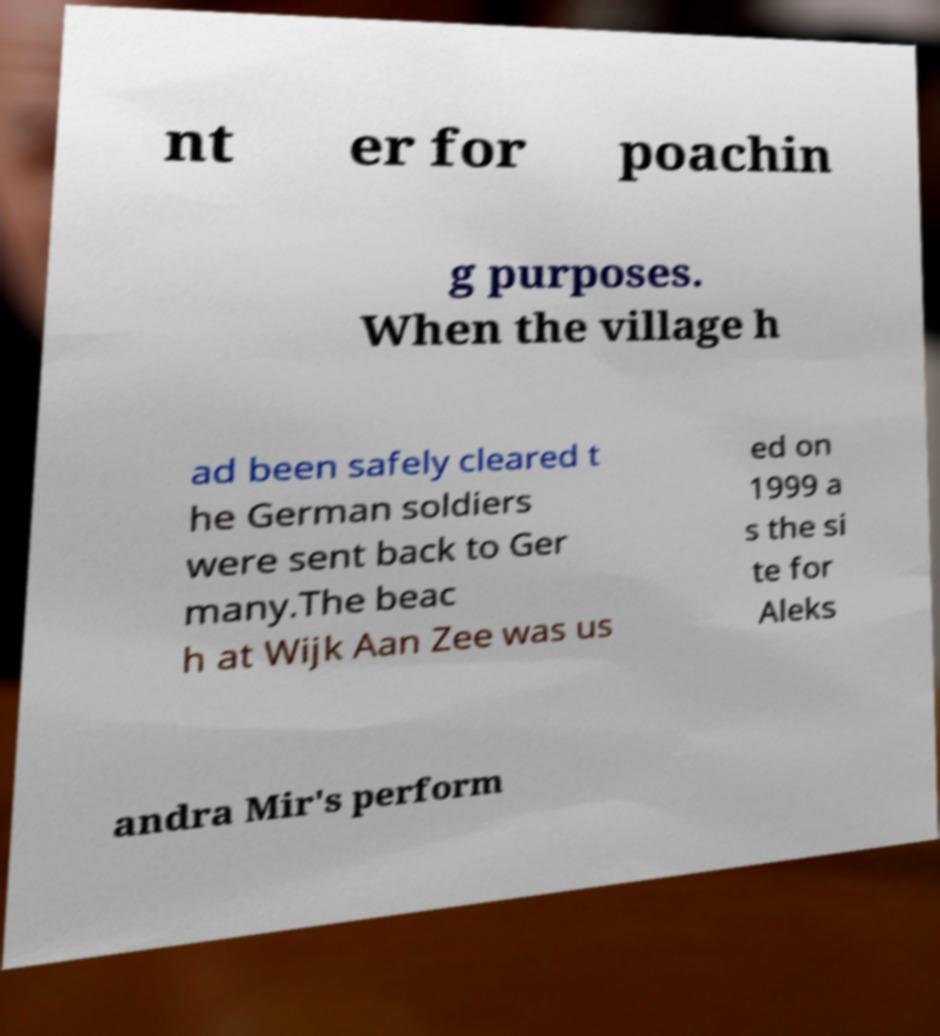Can you read and provide the text displayed in the image?This photo seems to have some interesting text. Can you extract and type it out for me? nt er for poachin g purposes. When the village h ad been safely cleared t he German soldiers were sent back to Ger many.The beac h at Wijk Aan Zee was us ed on 1999 a s the si te for Aleks andra Mir's perform 